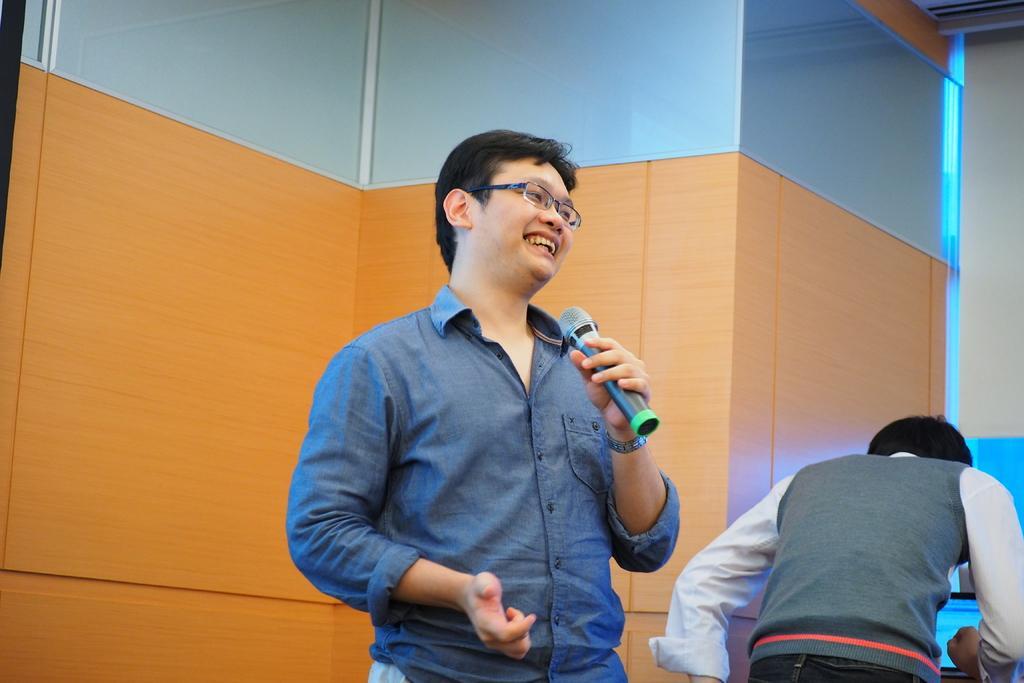Describe this image in one or two sentences. In this image I can see a person wearing blue colored shirt is standing and holding a microphone in his hand. In the background I can see the wall which is orange and blue in color, another person standing and the window blind which is white in color. 